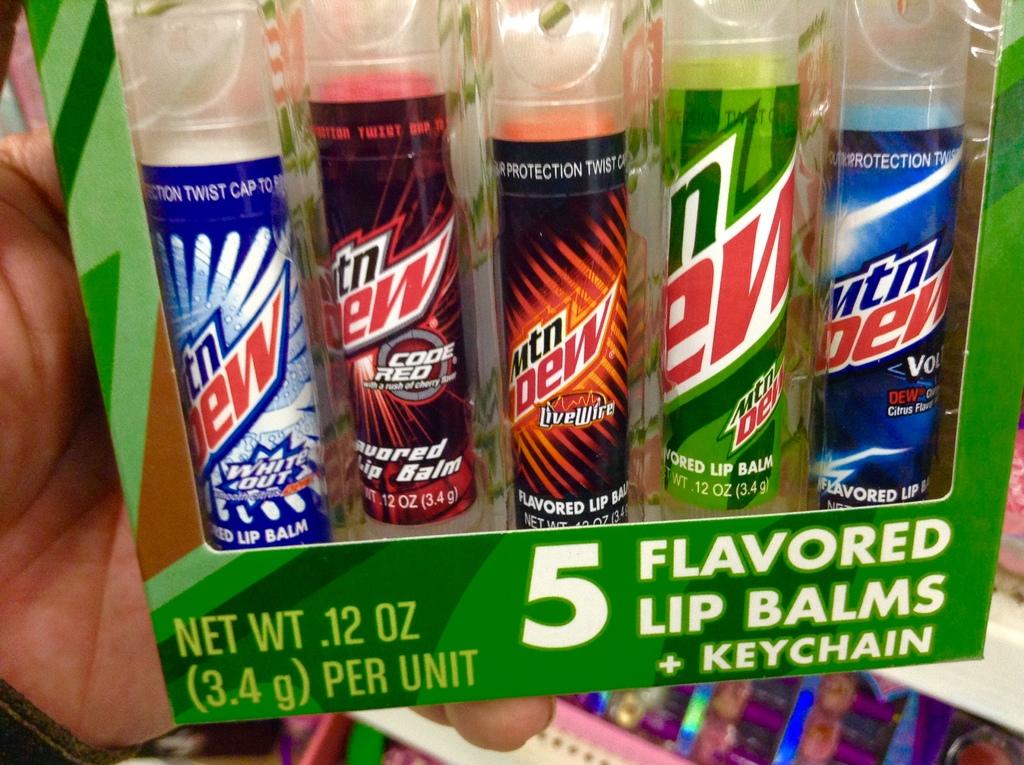How many flavors of lip balm?
Provide a succinct answer. 5. 